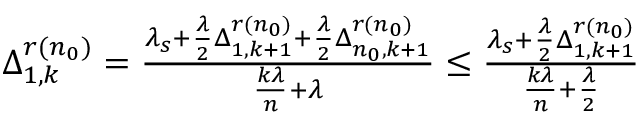Convert formula to latex. <formula><loc_0><loc_0><loc_500><loc_500>\begin{array} { r } { \, \Delta _ { 1 , k } ^ { r ( n _ { 0 } ) } = \frac { \lambda _ { s } + \frac { \lambda } { 2 } \Delta _ { 1 , k + 1 } ^ { r ( n _ { 0 } ) } + \frac { \lambda } { 2 } \Delta _ { n _ { 0 } , k + 1 } ^ { r ( n _ { 0 } ) } } { \frac { k \lambda } { n } + \lambda } \leq \frac { \lambda _ { s } + \frac { \lambda } { 2 } \Delta _ { 1 , k + 1 } ^ { r ( n _ { 0 } ) } } { \frac { k \lambda } { n } + \frac { \lambda } { 2 } } } \end{array}</formula> 